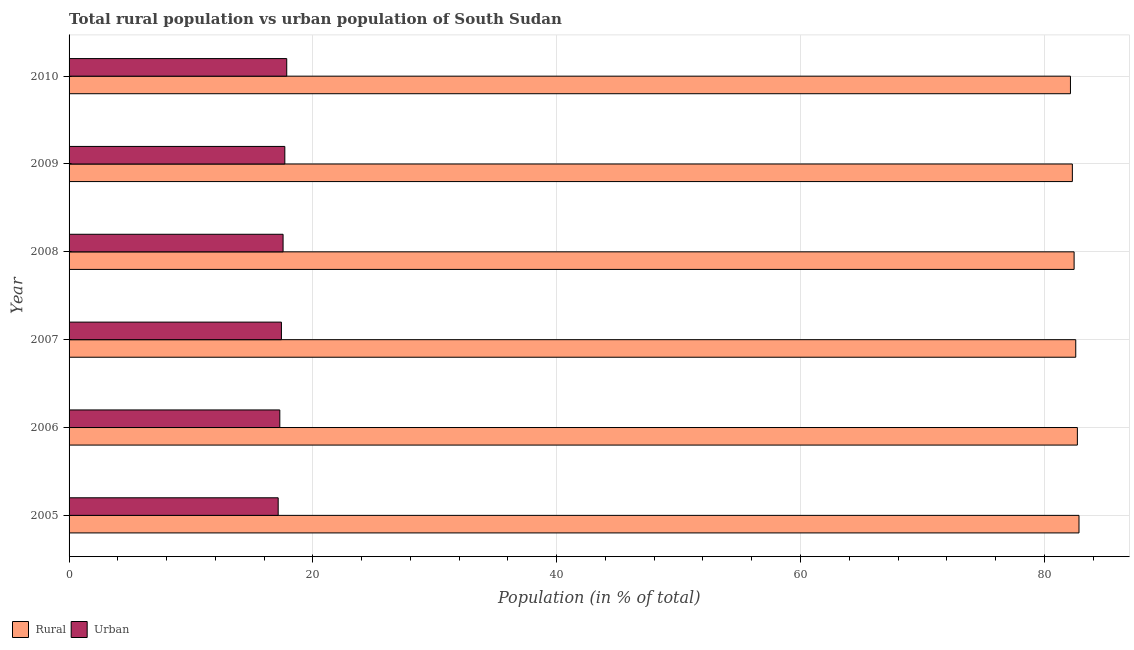How many different coloured bars are there?
Provide a short and direct response. 2. How many bars are there on the 1st tick from the bottom?
Offer a terse response. 2. What is the label of the 2nd group of bars from the top?
Provide a succinct answer. 2009. What is the urban population in 2008?
Offer a terse response. 17.55. Across all years, what is the maximum urban population?
Your response must be concise. 17.86. Across all years, what is the minimum rural population?
Ensure brevity in your answer.  82.14. In which year was the rural population maximum?
Ensure brevity in your answer.  2005. In which year was the rural population minimum?
Keep it short and to the point. 2010. What is the total urban population in the graph?
Provide a short and direct response. 104.97. What is the difference between the rural population in 2006 and that in 2007?
Ensure brevity in your answer.  0.13. What is the difference between the rural population in 2010 and the urban population in 2005?
Offer a very short reply. 64.99. What is the average urban population per year?
Your answer should be very brief. 17.5. In the year 2006, what is the difference between the rural population and urban population?
Offer a very short reply. 65.43. What is the difference between the highest and the second highest urban population?
Your answer should be compact. 0.16. In how many years, is the rural population greater than the average rural population taken over all years?
Your answer should be very brief. 3. Is the sum of the urban population in 2005 and 2007 greater than the maximum rural population across all years?
Keep it short and to the point. No. What does the 2nd bar from the top in 2008 represents?
Your answer should be compact. Rural. What does the 1st bar from the bottom in 2007 represents?
Offer a terse response. Rural. How many bars are there?
Provide a succinct answer. 12. Are all the bars in the graph horizontal?
Ensure brevity in your answer.  Yes. What is the difference between two consecutive major ticks on the X-axis?
Provide a succinct answer. 20. How many legend labels are there?
Offer a terse response. 2. What is the title of the graph?
Provide a succinct answer. Total rural population vs urban population of South Sudan. Does "Diesel" appear as one of the legend labels in the graph?
Offer a terse response. No. What is the label or title of the X-axis?
Provide a succinct answer. Population (in % of total). What is the label or title of the Y-axis?
Your answer should be very brief. Year. What is the Population (in % of total) in Rural in 2005?
Keep it short and to the point. 82.85. What is the Population (in % of total) in Urban in 2005?
Your answer should be very brief. 17.15. What is the Population (in % of total) in Rural in 2006?
Provide a short and direct response. 82.71. What is the Population (in % of total) in Urban in 2006?
Your answer should be very brief. 17.29. What is the Population (in % of total) in Rural in 2007?
Ensure brevity in your answer.  82.58. What is the Population (in % of total) in Urban in 2007?
Provide a succinct answer. 17.42. What is the Population (in % of total) in Rural in 2008?
Keep it short and to the point. 82.44. What is the Population (in % of total) of Urban in 2008?
Offer a very short reply. 17.55. What is the Population (in % of total) in Rural in 2009?
Your answer should be compact. 82.3. What is the Population (in % of total) in Urban in 2009?
Ensure brevity in your answer.  17.7. What is the Population (in % of total) of Rural in 2010?
Ensure brevity in your answer.  82.14. What is the Population (in % of total) in Urban in 2010?
Ensure brevity in your answer.  17.86. Across all years, what is the maximum Population (in % of total) of Rural?
Keep it short and to the point. 82.85. Across all years, what is the maximum Population (in % of total) in Urban?
Offer a very short reply. 17.86. Across all years, what is the minimum Population (in % of total) in Rural?
Provide a succinct answer. 82.14. Across all years, what is the minimum Population (in % of total) of Urban?
Your answer should be compact. 17.15. What is the total Population (in % of total) in Rural in the graph?
Offer a very short reply. 495.03. What is the total Population (in % of total) of Urban in the graph?
Provide a succinct answer. 104.97. What is the difference between the Population (in % of total) in Rural in 2005 and that in 2006?
Your answer should be very brief. 0.13. What is the difference between the Population (in % of total) of Urban in 2005 and that in 2006?
Provide a succinct answer. -0.13. What is the difference between the Population (in % of total) of Rural in 2005 and that in 2007?
Offer a terse response. 0.27. What is the difference between the Population (in % of total) of Urban in 2005 and that in 2007?
Your answer should be very brief. -0.27. What is the difference between the Population (in % of total) in Rural in 2005 and that in 2008?
Your response must be concise. 0.4. What is the difference between the Population (in % of total) of Urban in 2005 and that in 2008?
Your answer should be compact. -0.4. What is the difference between the Population (in % of total) in Rural in 2005 and that in 2009?
Your response must be concise. 0.55. What is the difference between the Population (in % of total) of Urban in 2005 and that in 2009?
Provide a short and direct response. -0.55. What is the difference between the Population (in % of total) of Rural in 2005 and that in 2010?
Ensure brevity in your answer.  0.7. What is the difference between the Population (in % of total) of Urban in 2005 and that in 2010?
Provide a succinct answer. -0.7. What is the difference between the Population (in % of total) in Rural in 2006 and that in 2007?
Your answer should be very brief. 0.13. What is the difference between the Population (in % of total) in Urban in 2006 and that in 2007?
Give a very brief answer. -0.13. What is the difference between the Population (in % of total) of Rural in 2006 and that in 2008?
Provide a short and direct response. 0.27. What is the difference between the Population (in % of total) of Urban in 2006 and that in 2008?
Make the answer very short. -0.27. What is the difference between the Population (in % of total) in Rural in 2006 and that in 2009?
Ensure brevity in your answer.  0.41. What is the difference between the Population (in % of total) of Urban in 2006 and that in 2009?
Your response must be concise. -0.41. What is the difference between the Population (in % of total) of Rural in 2006 and that in 2010?
Make the answer very short. 0.57. What is the difference between the Population (in % of total) in Urban in 2006 and that in 2010?
Provide a succinct answer. -0.57. What is the difference between the Population (in % of total) in Rural in 2007 and that in 2008?
Give a very brief answer. 0.14. What is the difference between the Population (in % of total) of Urban in 2007 and that in 2008?
Your answer should be very brief. -0.14. What is the difference between the Population (in % of total) of Rural in 2007 and that in 2009?
Your answer should be very brief. 0.28. What is the difference between the Population (in % of total) in Urban in 2007 and that in 2009?
Give a very brief answer. -0.28. What is the difference between the Population (in % of total) in Rural in 2007 and that in 2010?
Provide a short and direct response. 0.43. What is the difference between the Population (in % of total) of Urban in 2007 and that in 2010?
Your response must be concise. -0.43. What is the difference between the Population (in % of total) in Rural in 2008 and that in 2009?
Your answer should be very brief. 0.14. What is the difference between the Population (in % of total) of Urban in 2008 and that in 2009?
Your response must be concise. -0.14. What is the difference between the Population (in % of total) in Rural in 2009 and that in 2010?
Make the answer very short. 0.16. What is the difference between the Population (in % of total) in Urban in 2009 and that in 2010?
Ensure brevity in your answer.  -0.16. What is the difference between the Population (in % of total) in Rural in 2005 and the Population (in % of total) in Urban in 2006?
Keep it short and to the point. 65.56. What is the difference between the Population (in % of total) in Rural in 2005 and the Population (in % of total) in Urban in 2007?
Keep it short and to the point. 65.43. What is the difference between the Population (in % of total) in Rural in 2005 and the Population (in % of total) in Urban in 2008?
Your answer should be very brief. 65.29. What is the difference between the Population (in % of total) in Rural in 2005 and the Population (in % of total) in Urban in 2009?
Keep it short and to the point. 65.15. What is the difference between the Population (in % of total) in Rural in 2005 and the Population (in % of total) in Urban in 2010?
Offer a very short reply. 64.99. What is the difference between the Population (in % of total) of Rural in 2006 and the Population (in % of total) of Urban in 2007?
Make the answer very short. 65.29. What is the difference between the Population (in % of total) in Rural in 2006 and the Population (in % of total) in Urban in 2008?
Ensure brevity in your answer.  65.16. What is the difference between the Population (in % of total) in Rural in 2006 and the Population (in % of total) in Urban in 2009?
Keep it short and to the point. 65.01. What is the difference between the Population (in % of total) in Rural in 2006 and the Population (in % of total) in Urban in 2010?
Your answer should be very brief. 64.86. What is the difference between the Population (in % of total) in Rural in 2007 and the Population (in % of total) in Urban in 2008?
Make the answer very short. 65.03. What is the difference between the Population (in % of total) in Rural in 2007 and the Population (in % of total) in Urban in 2009?
Make the answer very short. 64.88. What is the difference between the Population (in % of total) of Rural in 2007 and the Population (in % of total) of Urban in 2010?
Make the answer very short. 64.72. What is the difference between the Population (in % of total) of Rural in 2008 and the Population (in % of total) of Urban in 2009?
Ensure brevity in your answer.  64.75. What is the difference between the Population (in % of total) in Rural in 2008 and the Population (in % of total) in Urban in 2010?
Provide a short and direct response. 64.59. What is the difference between the Population (in % of total) in Rural in 2009 and the Population (in % of total) in Urban in 2010?
Offer a very short reply. 64.45. What is the average Population (in % of total) in Rural per year?
Provide a succinct answer. 82.5. What is the average Population (in % of total) in Urban per year?
Your answer should be compact. 17.5. In the year 2005, what is the difference between the Population (in % of total) of Rural and Population (in % of total) of Urban?
Provide a succinct answer. 65.69. In the year 2006, what is the difference between the Population (in % of total) in Rural and Population (in % of total) in Urban?
Offer a terse response. 65.43. In the year 2007, what is the difference between the Population (in % of total) in Rural and Population (in % of total) in Urban?
Ensure brevity in your answer.  65.16. In the year 2008, what is the difference between the Population (in % of total) of Rural and Population (in % of total) of Urban?
Provide a short and direct response. 64.89. In the year 2009, what is the difference between the Population (in % of total) of Rural and Population (in % of total) of Urban?
Your response must be concise. 64.6. In the year 2010, what is the difference between the Population (in % of total) of Rural and Population (in % of total) of Urban?
Provide a short and direct response. 64.29. What is the ratio of the Population (in % of total) of Rural in 2005 to that in 2007?
Make the answer very short. 1. What is the ratio of the Population (in % of total) of Urban in 2005 to that in 2007?
Ensure brevity in your answer.  0.98. What is the ratio of the Population (in % of total) of Urban in 2005 to that in 2008?
Your answer should be very brief. 0.98. What is the ratio of the Population (in % of total) in Rural in 2005 to that in 2009?
Your answer should be very brief. 1.01. What is the ratio of the Population (in % of total) in Urban in 2005 to that in 2009?
Give a very brief answer. 0.97. What is the ratio of the Population (in % of total) in Rural in 2005 to that in 2010?
Provide a succinct answer. 1.01. What is the ratio of the Population (in % of total) of Urban in 2005 to that in 2010?
Your answer should be very brief. 0.96. What is the ratio of the Population (in % of total) in Urban in 2006 to that in 2007?
Provide a succinct answer. 0.99. What is the ratio of the Population (in % of total) in Urban in 2006 to that in 2008?
Keep it short and to the point. 0.98. What is the ratio of the Population (in % of total) in Rural in 2006 to that in 2009?
Provide a short and direct response. 1. What is the ratio of the Population (in % of total) in Urban in 2006 to that in 2009?
Keep it short and to the point. 0.98. What is the ratio of the Population (in % of total) of Rural in 2006 to that in 2010?
Provide a short and direct response. 1.01. What is the ratio of the Population (in % of total) in Urban in 2006 to that in 2010?
Your response must be concise. 0.97. What is the ratio of the Population (in % of total) in Rural in 2007 to that in 2008?
Keep it short and to the point. 1. What is the ratio of the Population (in % of total) in Rural in 2007 to that in 2009?
Provide a succinct answer. 1. What is the ratio of the Population (in % of total) of Urban in 2007 to that in 2009?
Give a very brief answer. 0.98. What is the ratio of the Population (in % of total) in Rural in 2007 to that in 2010?
Give a very brief answer. 1.01. What is the ratio of the Population (in % of total) in Urban in 2007 to that in 2010?
Give a very brief answer. 0.98. What is the ratio of the Population (in % of total) in Urban in 2008 to that in 2010?
Offer a terse response. 0.98. What is the ratio of the Population (in % of total) in Urban in 2009 to that in 2010?
Provide a short and direct response. 0.99. What is the difference between the highest and the second highest Population (in % of total) in Rural?
Provide a succinct answer. 0.13. What is the difference between the highest and the second highest Population (in % of total) of Urban?
Ensure brevity in your answer.  0.16. What is the difference between the highest and the lowest Population (in % of total) of Rural?
Make the answer very short. 0.7. What is the difference between the highest and the lowest Population (in % of total) in Urban?
Offer a very short reply. 0.7. 